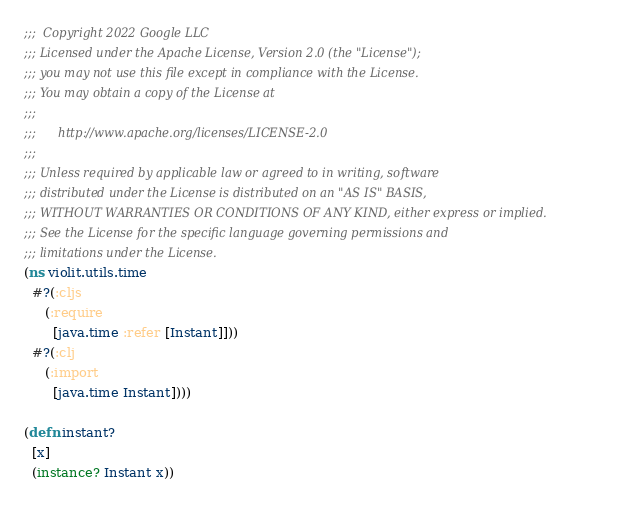<code> <loc_0><loc_0><loc_500><loc_500><_Clojure_>;;;  Copyright 2022 Google LLC
;;; Licensed under the Apache License, Version 2.0 (the "License");
;;; you may not use this file except in compliance with the License.
;;; You may obtain a copy of the License at
;;;
;;;      http://www.apache.org/licenses/LICENSE-2.0
;;;
;;; Unless required by applicable law or agreed to in writing, software
;;; distributed under the License is distributed on an "AS IS" BASIS,
;;; WITHOUT WARRANTIES OR CONDITIONS OF ANY KIND, either express or implied.
;;; See the License for the specific language governing permissions and
;;; limitations under the License.
(ns violit.utils.time
  #?(:cljs
     (:require
       [java.time :refer [Instant]]))
  #?(:clj
     (:import
       [java.time Instant])))

(defn instant?
  [x]
  (instance? Instant x))
</code> 